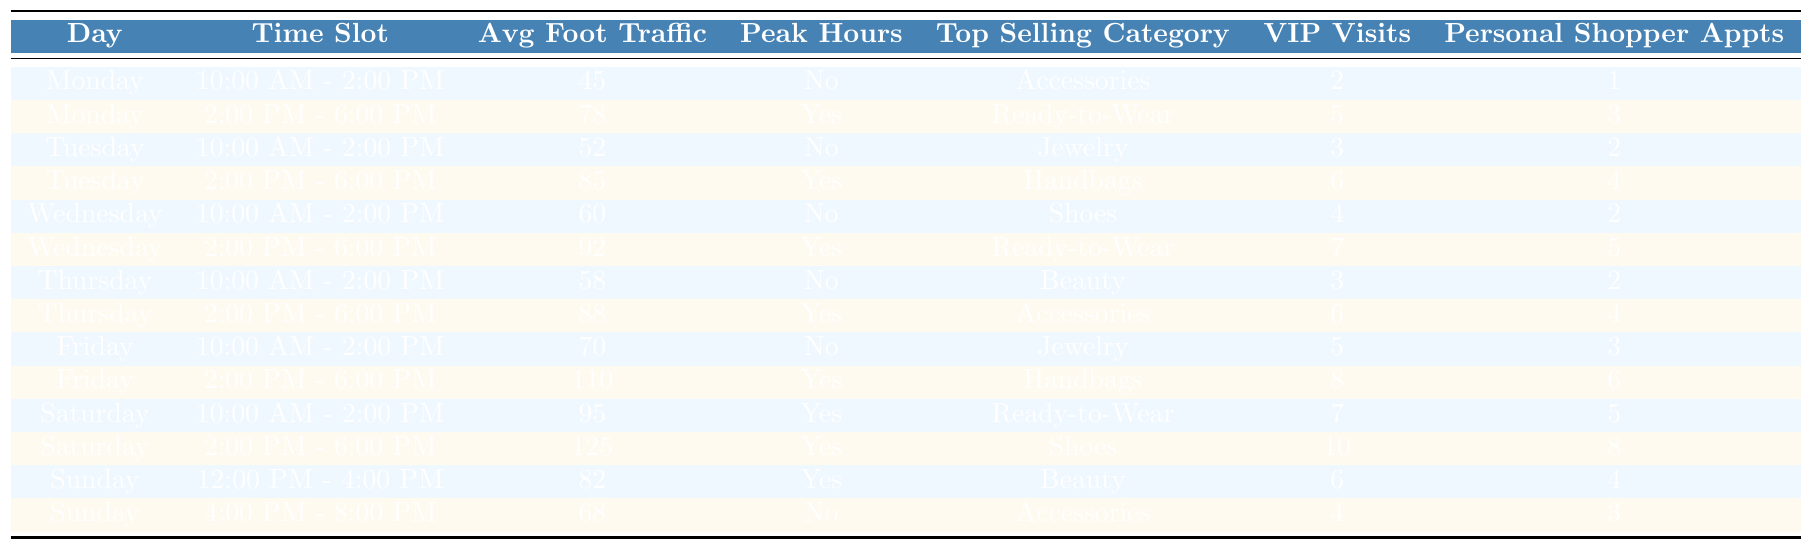What is the average foot traffic on Saturdays during the 2:00 PM - 6:00 PM slot? The average foot traffic for Saturday from 2:00 PM to 6:00 PM is 125 according to the table.
Answer: 125 Which time slot has the highest average foot traffic? The time slot with the highest average foot traffic is Friday from 2:00 PM to 6:00 PM, which has 110 foot traffic.
Answer: Friday 2:00 PM - 6:00 PM On which day is the top-selling category 'Accessories' found? The top-selling category 'Accessories' is identified on Monday during the 10:00 AM - 2:00 PM slot and also on Thursday from 2:00 PM to 6:00 PM.
Answer: Monday and Thursday How many VIP client visits were there in total for the time slots on Tuesday? The total VIP client visits on Tuesday is the sum of 3 (10:00 AM - 2:00 PM) and 6 (2:00 PM - 6:00 PM), yielding 9 VIP visits in total.
Answer: 9 Is there an increase in average foot traffic from Monday to Tuesday in the afternoon slot? On Monday from 2:00 PM to 6:00 PM, the foot traffic is 78, and on Tuesday during the same slot, it is 85, indicating an increase of 7 foot traffic.
Answer: Yes Which day had the most personal shopper appointments? Saturday had the most personal shopper appointments with a total of 8 (5 in the morning and 3 in the afternoon).
Answer: Saturday Is there any time slot on Sunday classified as peak hours? Yes, the Sunday slot from 12:00 PM to 4:00 PM is classified as peak hours.
Answer: Yes What is the difference in average foot traffic between the highest and lowest recorded time slots? The highest average foot traffic is 125 (Saturday 2:00 PM - 6:00 PM) and the lowest is 45 (Monday 10:00 AM - 2:00 PM), so the difference is 125 - 45 = 80.
Answer: 80 Which top-selling category consistently appears more than once throughout the week? The 'Ready-to-Wear' category appears on both Wednesday and Saturday, indicating consistency throughout the week.
Answer: Ready-to-Wear What percentage of personal shopper appointments on Friday are for VIP clients? There are 6 personal shopper appointments on Friday, all of which are for VIP clients (5 from 10:00 AM - 2:00 PM and 6 from 2:00 PM - 6:00 PM). The percentage is (6/6) * 100% = 100%.
Answer: 100% 